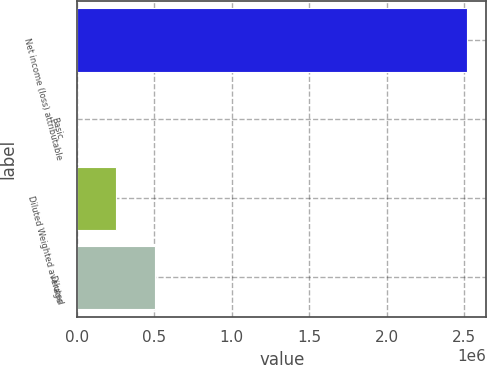<chart> <loc_0><loc_0><loc_500><loc_500><bar_chart><fcel>Net income (loss) attributable<fcel>Basic<fcel>Diluted Weighted average<fcel>Diluted<nl><fcel>2.51776e+06<fcel>8.8<fcel>251784<fcel>503560<nl></chart> 